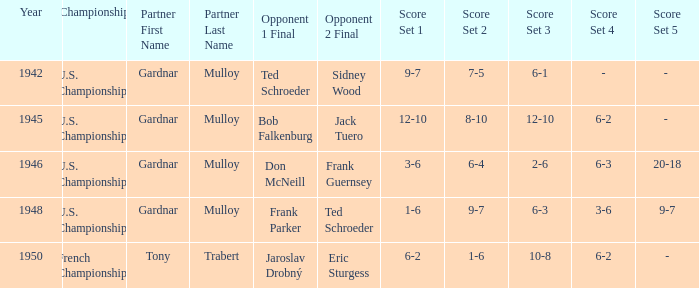Which opponents in the u.s. championships played after 1945 and had a score of 3–6, 6–4, 2–6, 6–3, 20–18? Don McNeill Frank Guernsey. 